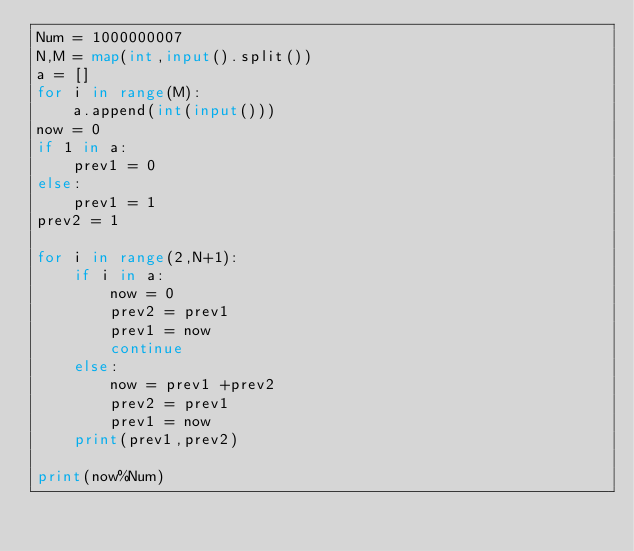Convert code to text. <code><loc_0><loc_0><loc_500><loc_500><_Python_>Num = 1000000007 
N,M = map(int,input().split())
a = []
for i in range(M):
    a.append(int(input()))
now = 0
if 1 in a:
    prev1 = 0
else:
    prev1 = 1
prev2 = 1

for i in range(2,N+1):
    if i in a:
        now = 0
        prev2 = prev1
        prev1 = now 
        continue
    else:
        now = prev1 +prev2
        prev2 = prev1
        prev1 = now
    print(prev1,prev2)

print(now%Num)</code> 